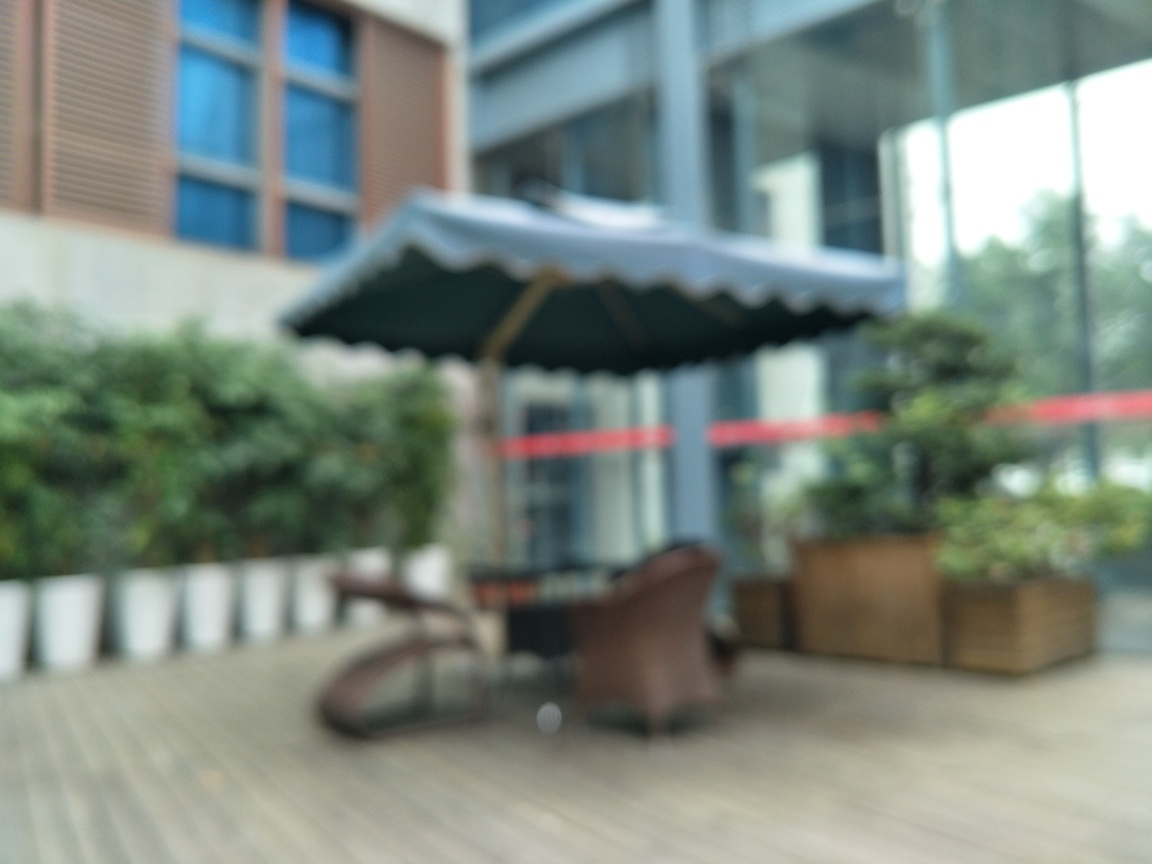What time of day does this image likely represent? It's difficult to determine the exact time of day due to the image's lack of focus. However, the relatively even lighting and absence of heavy shadows suggest it could be an overcast day or possibly during a time when the sunlight is not at its peak intensity, such as morning or late afternoon. 